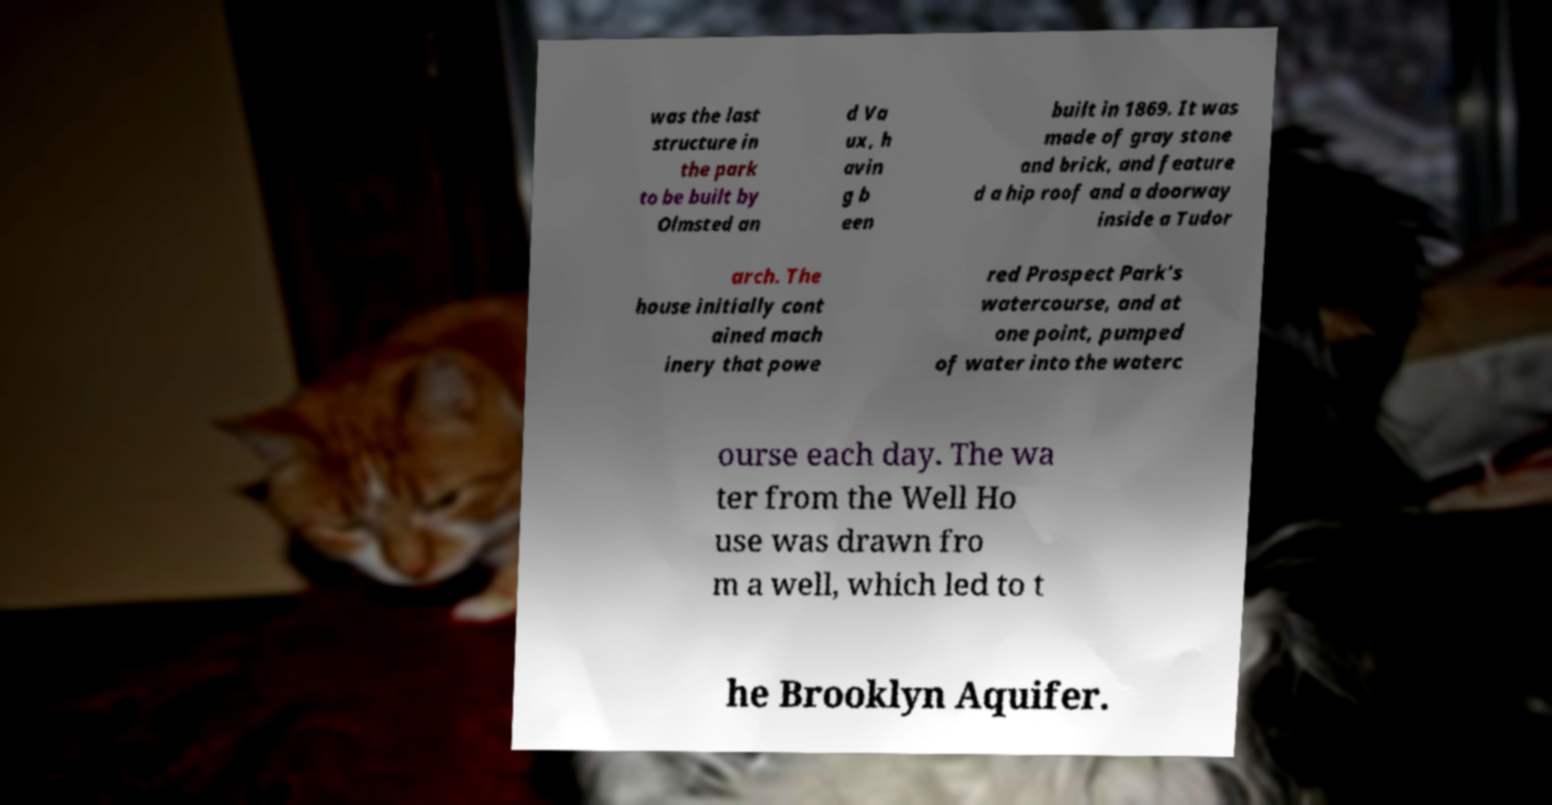There's text embedded in this image that I need extracted. Can you transcribe it verbatim? was the last structure in the park to be built by Olmsted an d Va ux, h avin g b een built in 1869. It was made of gray stone and brick, and feature d a hip roof and a doorway inside a Tudor arch. The house initially cont ained mach inery that powe red Prospect Park's watercourse, and at one point, pumped of water into the waterc ourse each day. The wa ter from the Well Ho use was drawn fro m a well, which led to t he Brooklyn Aquifer. 